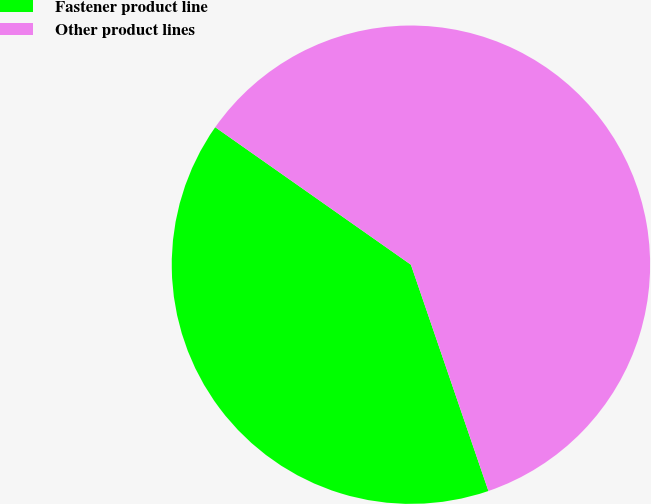Convert chart. <chart><loc_0><loc_0><loc_500><loc_500><pie_chart><fcel>Fastener product line<fcel>Other product lines<nl><fcel>40.0%<fcel>60.0%<nl></chart> 